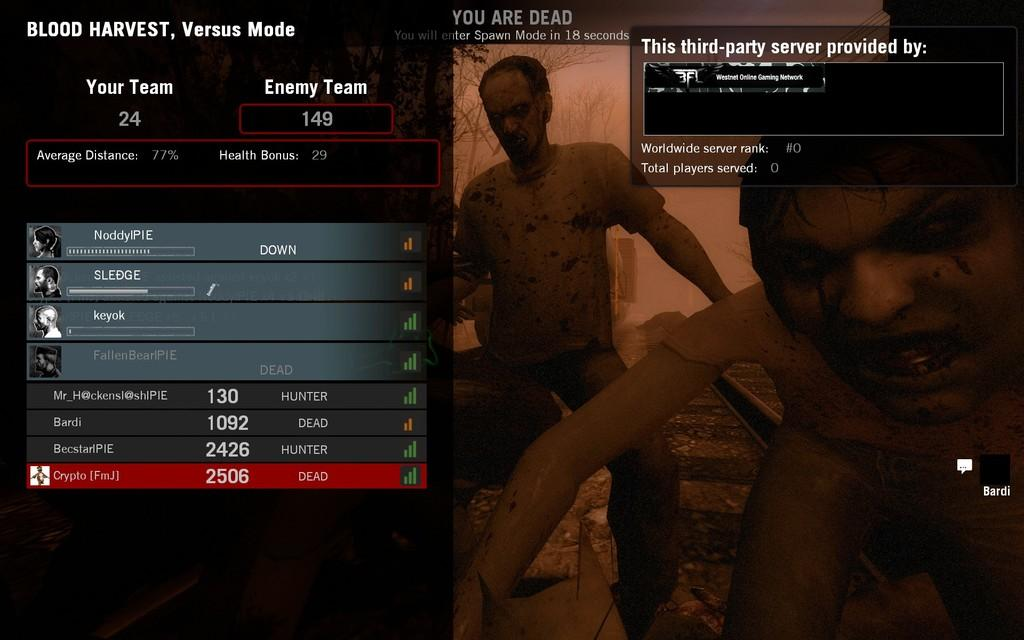What is depicted on the poster in the image? There is a poster with images of zombies in the picture. What is mentioned beside the poster? There is a "blood harvest versus mode" mentioned beside the poster. How many horns can be seen on the zombies in the image? There are no horns visible on the zombies in the image. What type of crib is present in the image? There is no crib present in the image. 